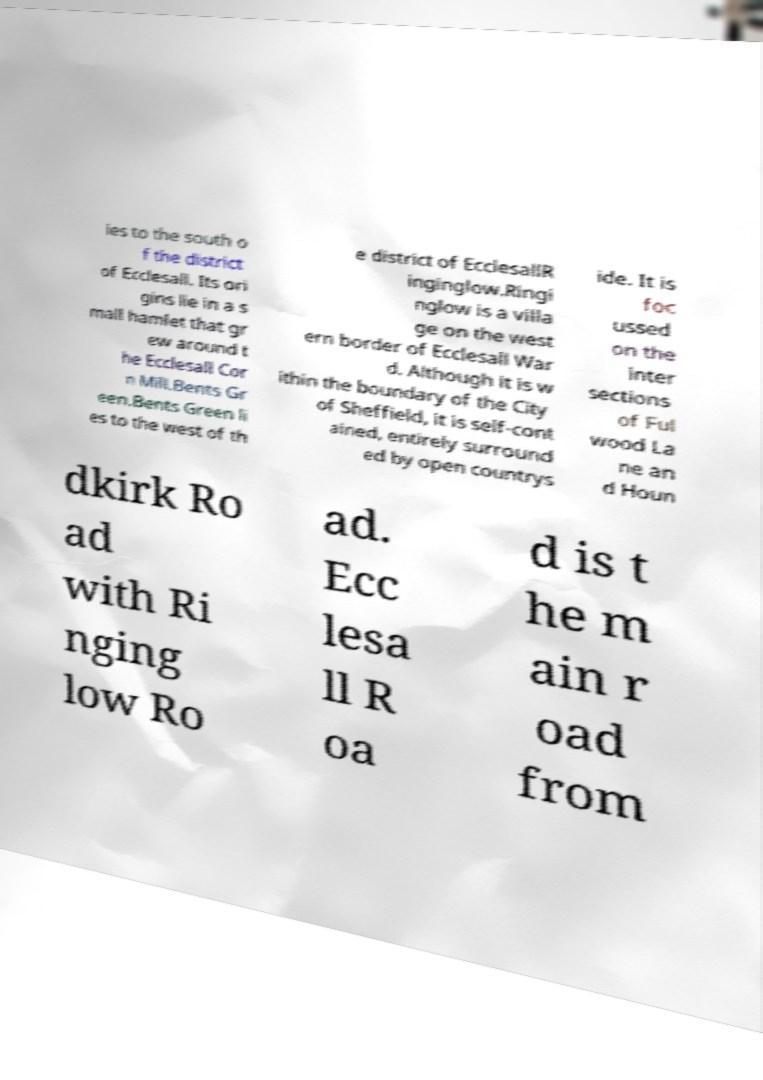For documentation purposes, I need the text within this image transcribed. Could you provide that? ies to the south o f the district of Ecclesall. Its ori gins lie in a s mall hamlet that gr ew around t he Ecclesall Cor n Mill.Bents Gr een.Bents Green li es to the west of th e district of EcclesallR inginglow.Ringi nglow is a villa ge on the west ern border of Ecclesall War d. Although it is w ithin the boundary of the City of Sheffield, it is self-cont ained, entirely surround ed by open countrys ide. It is foc ussed on the inter sections of Ful wood La ne an d Houn dkirk Ro ad with Ri nging low Ro ad. Ecc lesa ll R oa d is t he m ain r oad from 